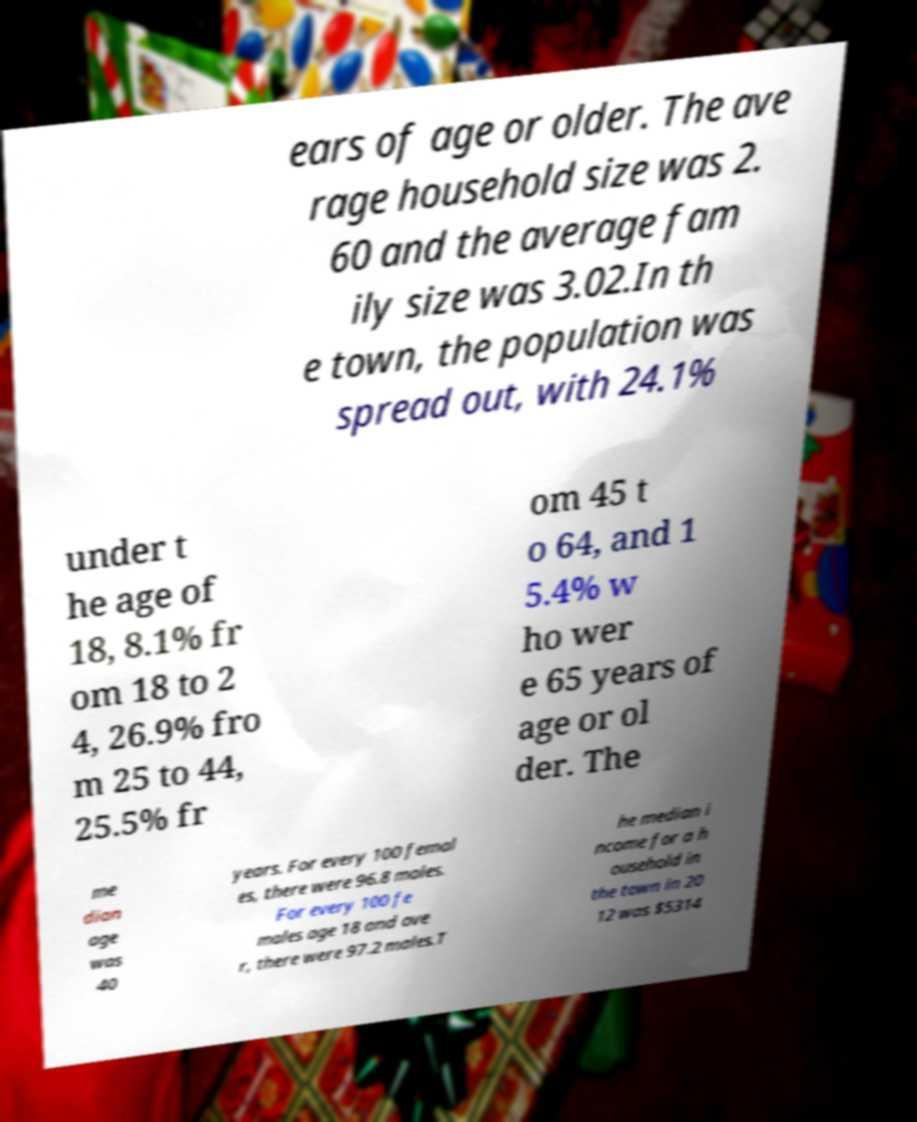Can you accurately transcribe the text from the provided image for me? ears of age or older. The ave rage household size was 2. 60 and the average fam ily size was 3.02.In th e town, the population was spread out, with 24.1% under t he age of 18, 8.1% fr om 18 to 2 4, 26.9% fro m 25 to 44, 25.5% fr om 45 t o 64, and 1 5.4% w ho wer e 65 years of age or ol der. The me dian age was 40 years. For every 100 femal es, there were 96.8 males. For every 100 fe males age 18 and ove r, there were 97.2 males.T he median i ncome for a h ousehold in the town in 20 12 was $5314 